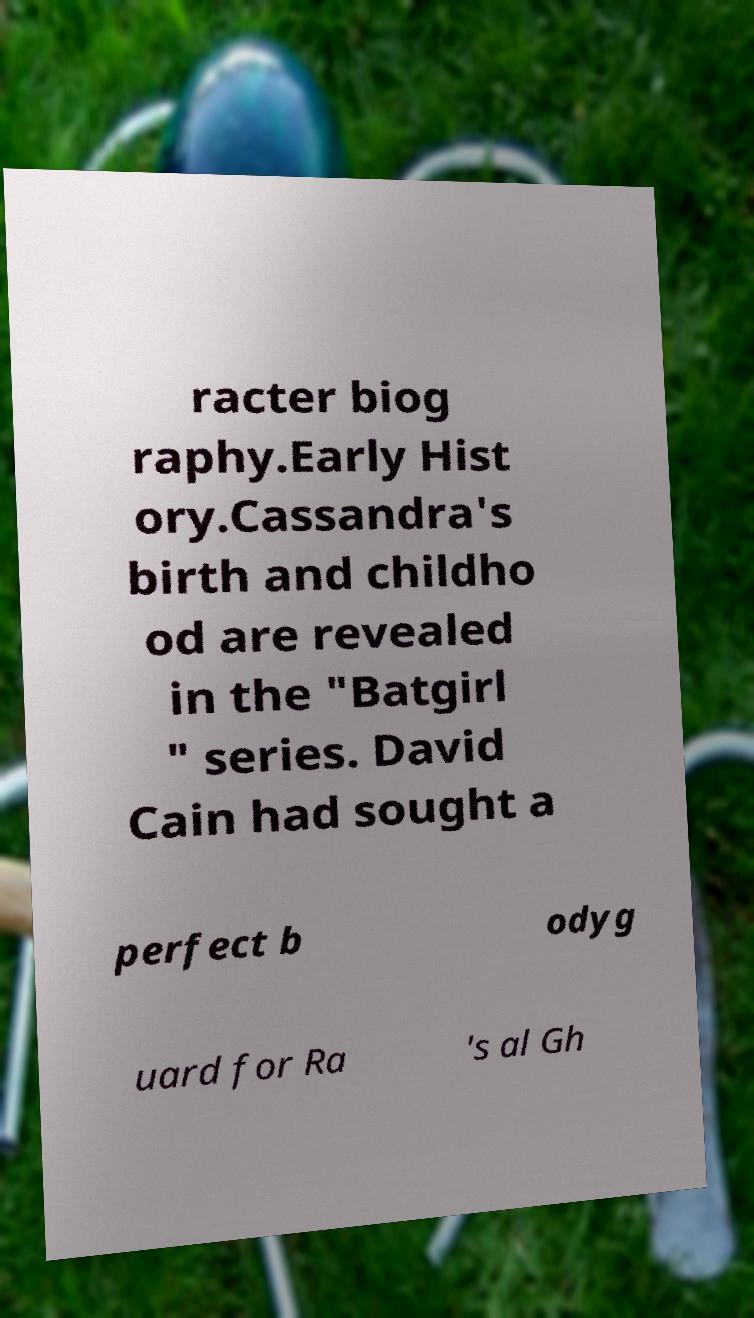Can you read and provide the text displayed in the image?This photo seems to have some interesting text. Can you extract and type it out for me? racter biog raphy.Early Hist ory.Cassandra's birth and childho od are revealed in the "Batgirl " series. David Cain had sought a perfect b odyg uard for Ra 's al Gh 